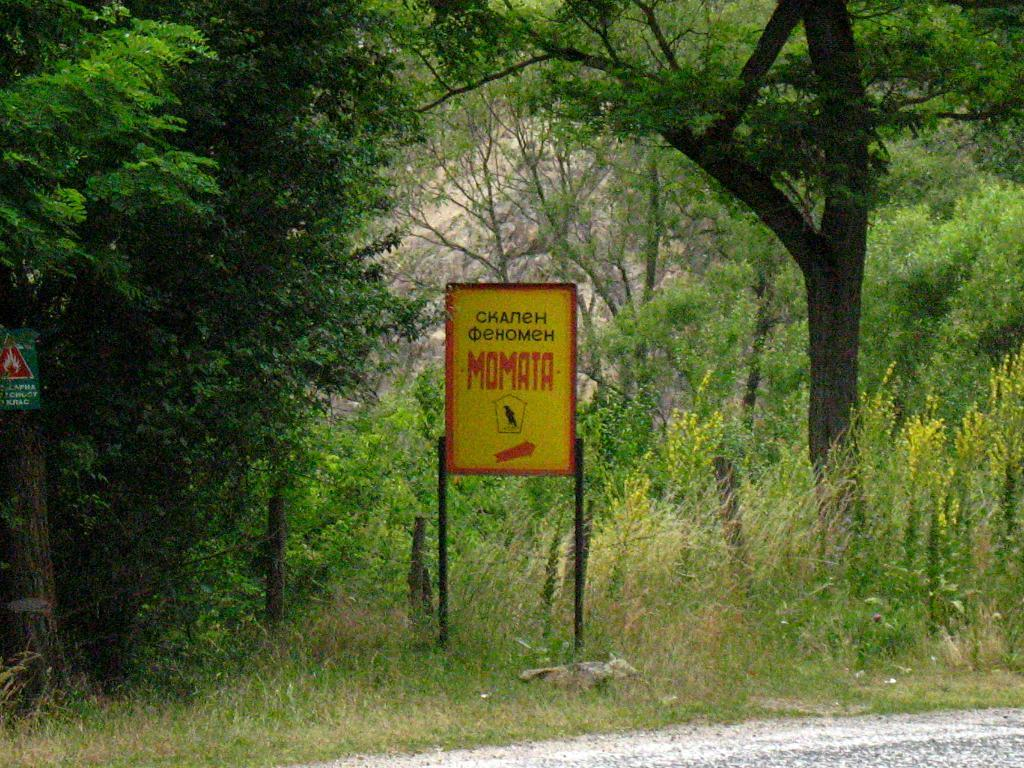<image>
Present a compact description of the photo's key features. A sign in the woods has the word MOMATA written in the middle with an arrow pointing to the right. 